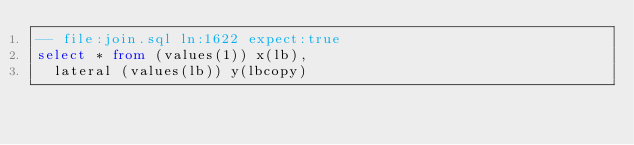Convert code to text. <code><loc_0><loc_0><loc_500><loc_500><_SQL_>-- file:join.sql ln:1622 expect:true
select * from (values(1)) x(lb),
  lateral (values(lb)) y(lbcopy)
</code> 